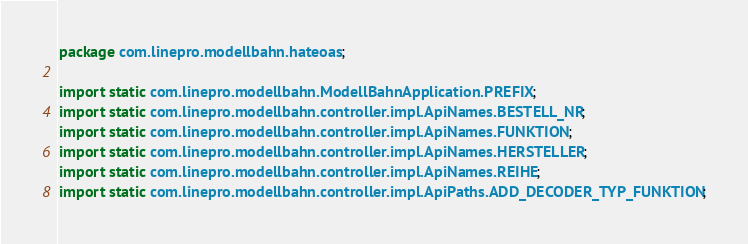<code> <loc_0><loc_0><loc_500><loc_500><_Java_>package com.linepro.modellbahn.hateoas;

import static com.linepro.modellbahn.ModellBahnApplication.PREFIX;
import static com.linepro.modellbahn.controller.impl.ApiNames.BESTELL_NR;
import static com.linepro.modellbahn.controller.impl.ApiNames.FUNKTION;
import static com.linepro.modellbahn.controller.impl.ApiNames.HERSTELLER;
import static com.linepro.modellbahn.controller.impl.ApiNames.REIHE;
import static com.linepro.modellbahn.controller.impl.ApiPaths.ADD_DECODER_TYP_FUNKTION;</code> 